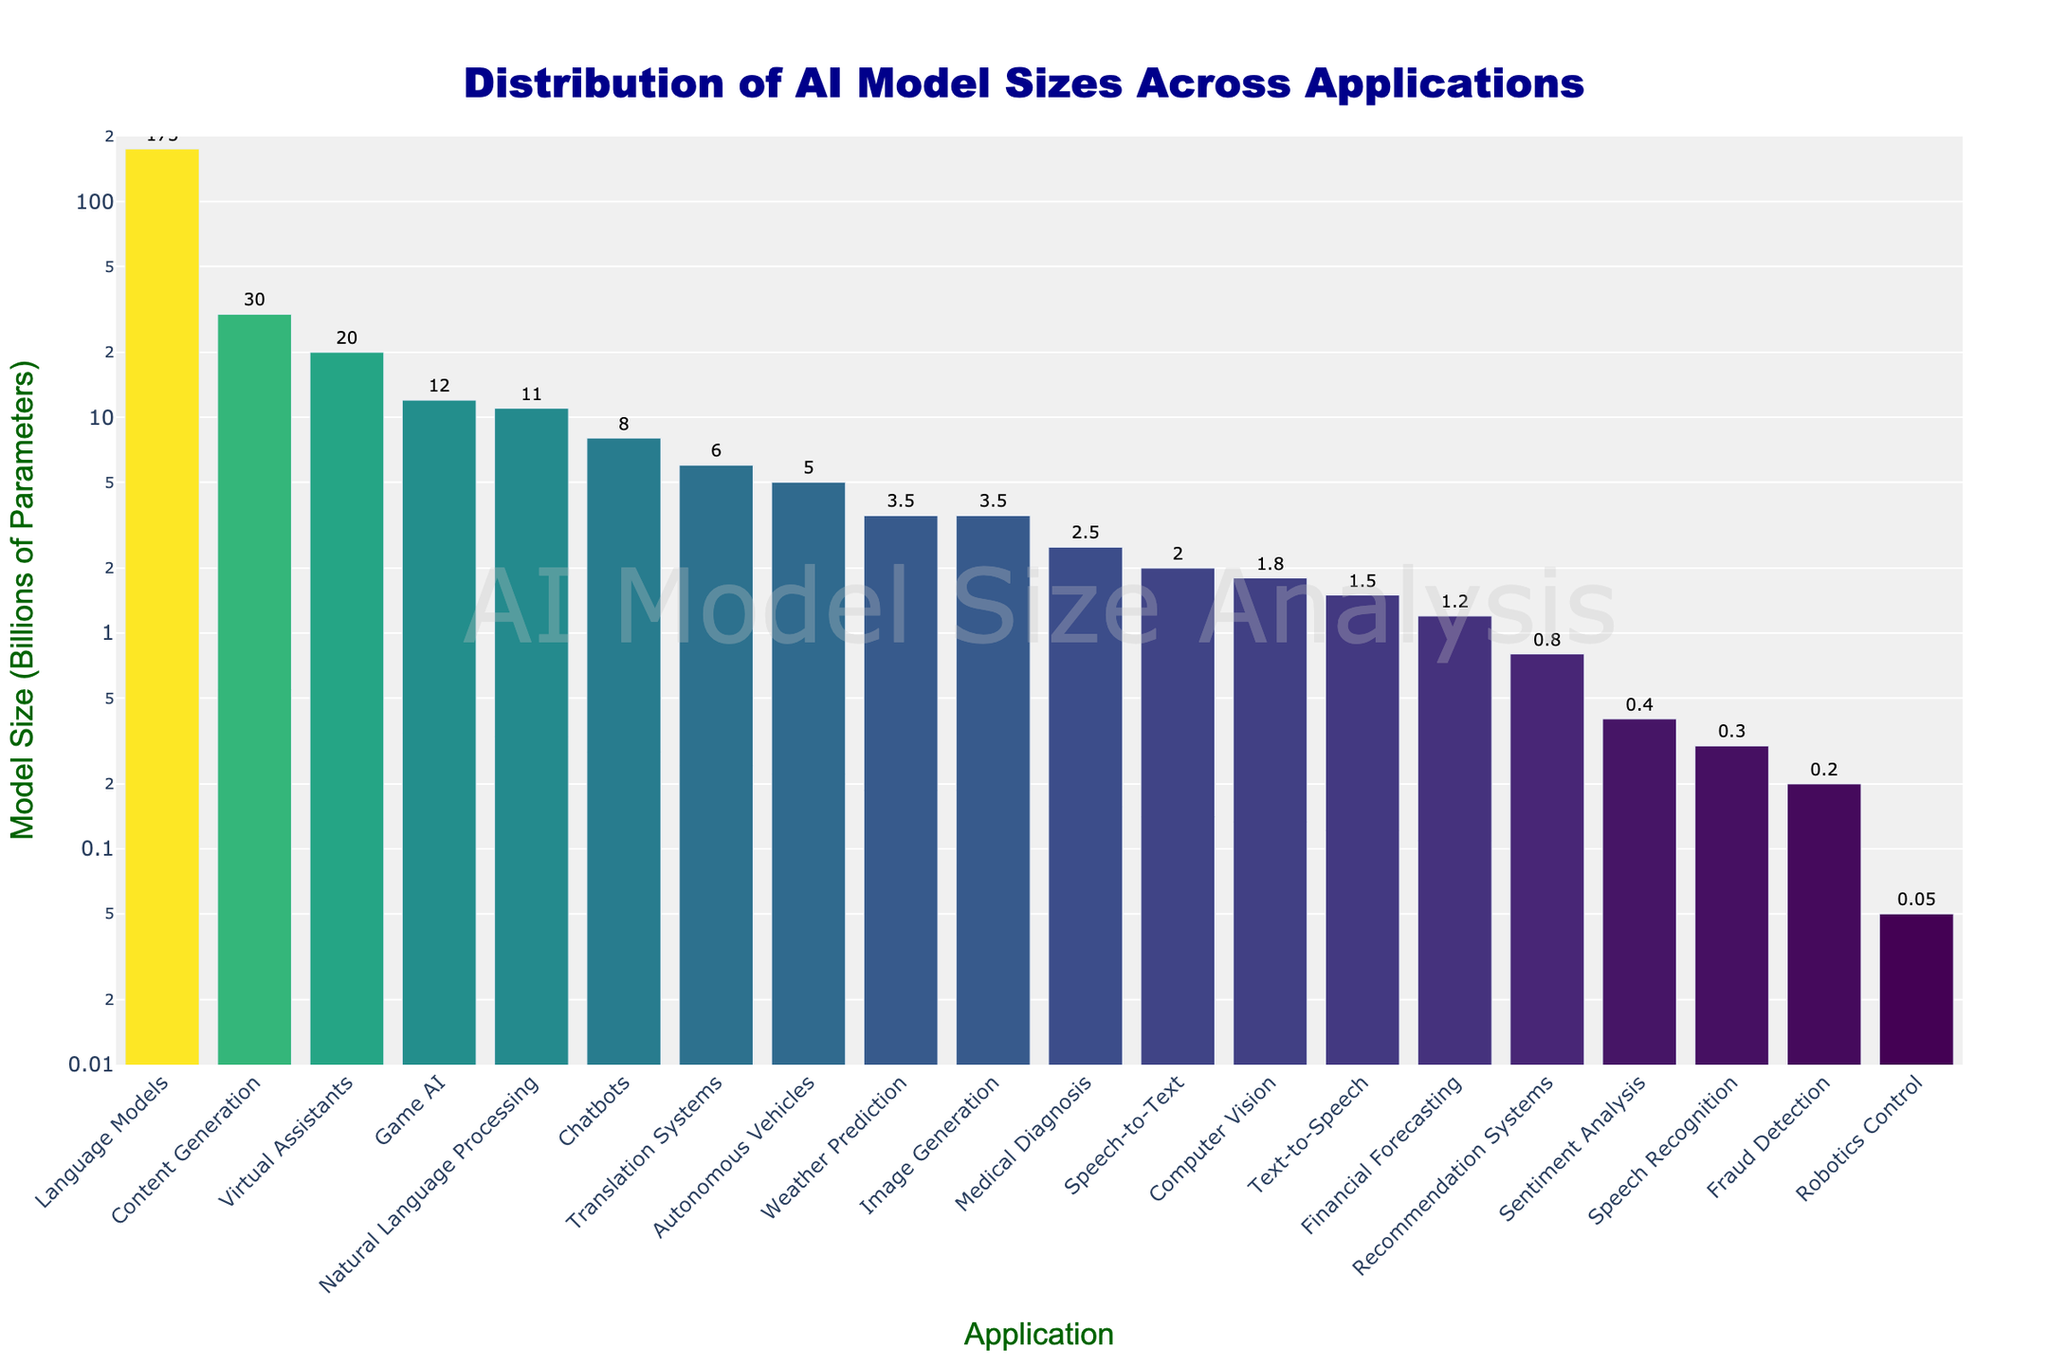Which application has the largest AI model size? By looking at the bar heights, the bar labeled "Language Models" is the tallest, indicating it has the largest model size.
Answer: Language Models Which applications have AI model sizes smaller than 1 billion parameters? The bars for "Speech Recognition," "Robotics Control," "Fraud Detection," and "Sentiment Analysis" are all shorter than the line marked 1 on the y-axis.
Answer: Speech Recognition, Robotics Control, Fraud Detection, Sentiment Analysis How does the model size for Computer Vision compare to Medical Diagnosis? By comparing the bar heights and hover texts, the model size for Computer Vision (1.8B) is smaller than that of Medical Diagnosis (2.5B).
Answer: Computer Vision is smaller What is the total model size for Game AI and Translation Systems combined? Summing the values from the hover texts: 12B (Game AI) + 6B (Translation Systems) gives 18B.
Answer: 18B How many applications have AI model sizes greater than or equal to 10 billion parameters? By counting bars taller than the line marked 10 on the y-axis: Language Models, Virtual Assistants, Content Generation, and Game AI.
Answer: 4 What is the ratio of the model size of Natural Language Processing to that of Speech-to-Text? Dividing the values from the hover texts: 11B (NLP)/2B (Speech-to-Text) yields a ratio of 5.5.
Answer: 5.5 Which application has a model size of approximately 0.8 billion parameters? The bar labeled "Recommendation Systems" has a height matching the value 0.8B in the hover text.
Answer: Recommendation Systems Which application has a model size closest to that of Image Generation? Comparing values in hover texts, both Image Generation and Weather Prediction have a model size of 3.5B.
Answer: Weather Prediction Is the model size for Chatbots larger or smaller than that for Content Generation? By comparing the bar heights and hover texts, the model size for Chatbots (8B) is smaller than that for Content Generation (30B).
Answer: smaller What's the average model size of Robotics Control, Chatbots, and Financial Forecasting? Sum their sizes from the hover texts: 0.05B + 8B + 1.2B = 9.25B, then divide by 3 to get an average of approximately 3.08B.
Answer: 3.08B 